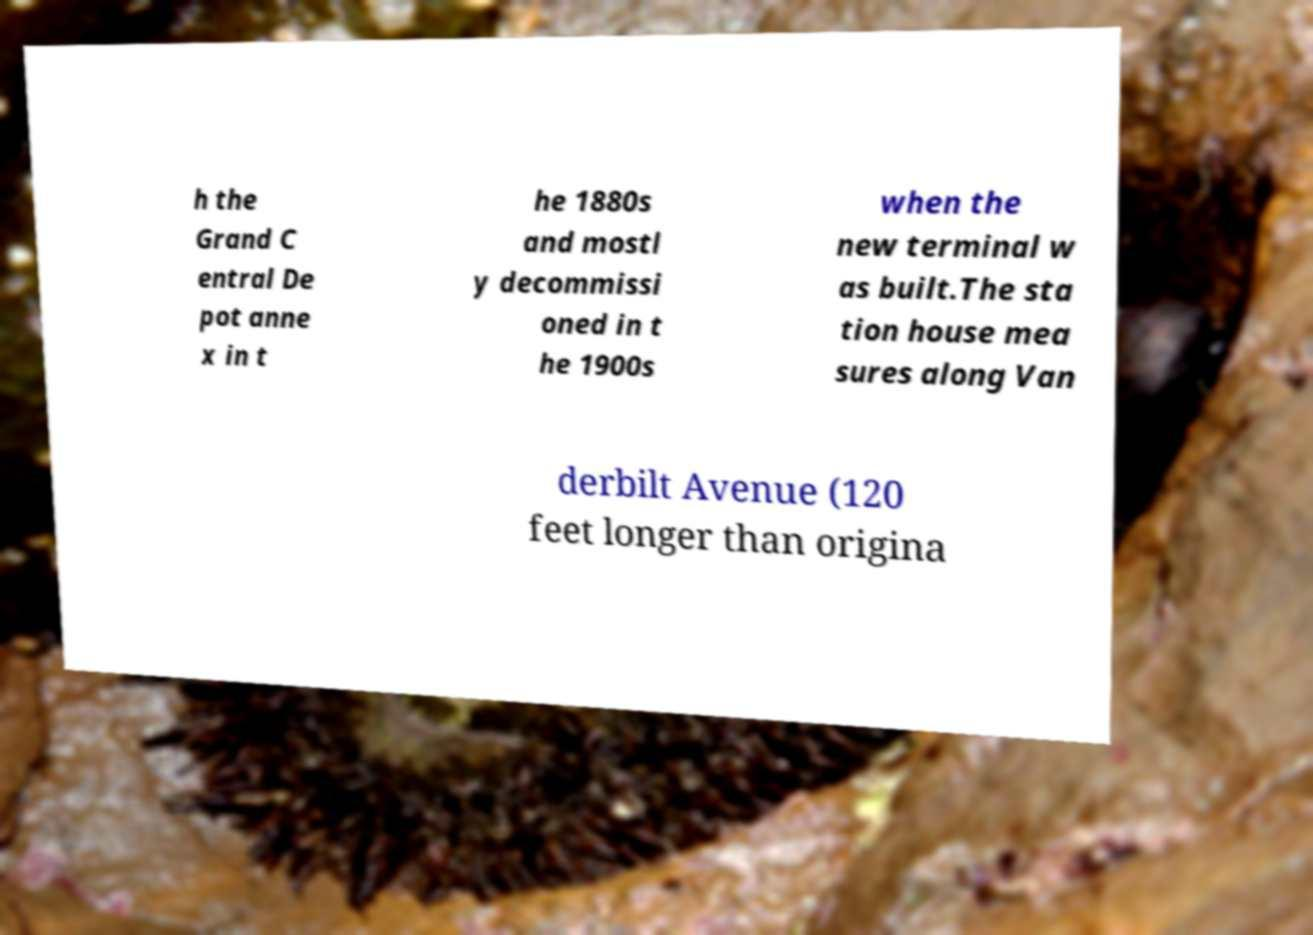There's text embedded in this image that I need extracted. Can you transcribe it verbatim? h the Grand C entral De pot anne x in t he 1880s and mostl y decommissi oned in t he 1900s when the new terminal w as built.The sta tion house mea sures along Van derbilt Avenue (120 feet longer than origina 